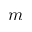<formula> <loc_0><loc_0><loc_500><loc_500>m</formula> 